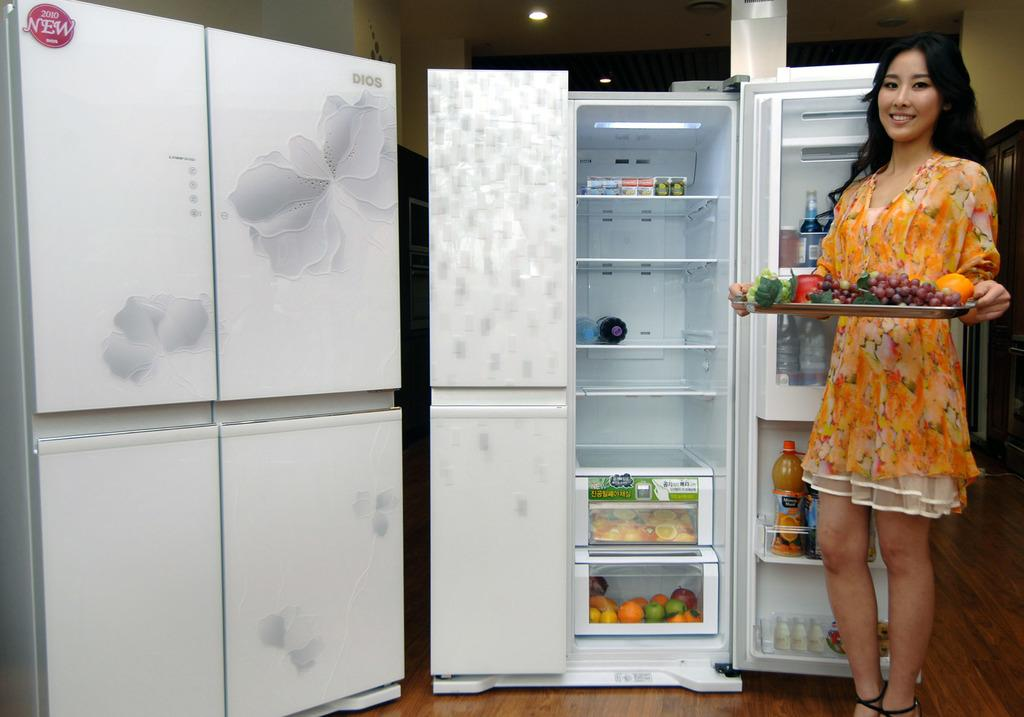Provide a one-sentence caption for the provided image. A women holding a tray of fruit in front of a DIOS refrigerator open door. 